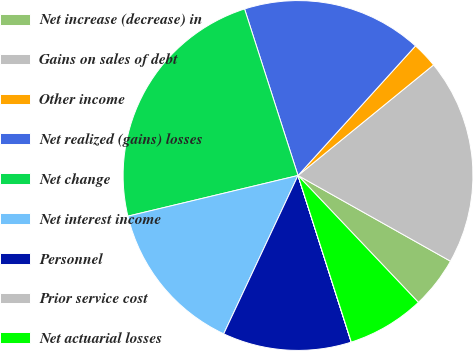Convert chart to OTSL. <chart><loc_0><loc_0><loc_500><loc_500><pie_chart><fcel>Net increase (decrease) in<fcel>Gains on sales of debt<fcel>Other income<fcel>Net realized (gains) losses<fcel>Net change<fcel>Net interest income<fcel>Personnel<fcel>Prior service cost<fcel>Net actuarial losses<nl><fcel>4.77%<fcel>19.04%<fcel>2.39%<fcel>16.66%<fcel>23.79%<fcel>14.28%<fcel>11.9%<fcel>0.01%<fcel>7.15%<nl></chart> 